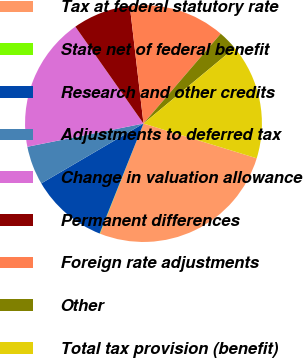Convert chart to OTSL. <chart><loc_0><loc_0><loc_500><loc_500><pie_chart><fcel>Tax at federal statutory rate<fcel>State net of federal benefit<fcel>Research and other credits<fcel>Adjustments to deferred tax<fcel>Change in valuation allowance<fcel>Permanent differences<fcel>Foreign rate adjustments<fcel>Other<fcel>Total tax provision (benefit)<nl><fcel>26.25%<fcel>0.05%<fcel>10.53%<fcel>5.29%<fcel>18.39%<fcel>7.91%<fcel>13.15%<fcel>2.67%<fcel>15.77%<nl></chart> 